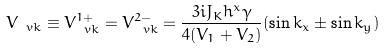Convert formula to latex. <formula><loc_0><loc_0><loc_500><loc_500>V _ { \ v k } \equiv V ^ { 1 + } _ { \ v k } = V ^ { 2 - } _ { \ v k } = \frac { 3 i J _ { K } h ^ { x } \gamma } { 4 ( V _ { 1 } + V _ { 2 } ) } ( \sin k _ { x } \pm \sin k _ { y } )</formula> 